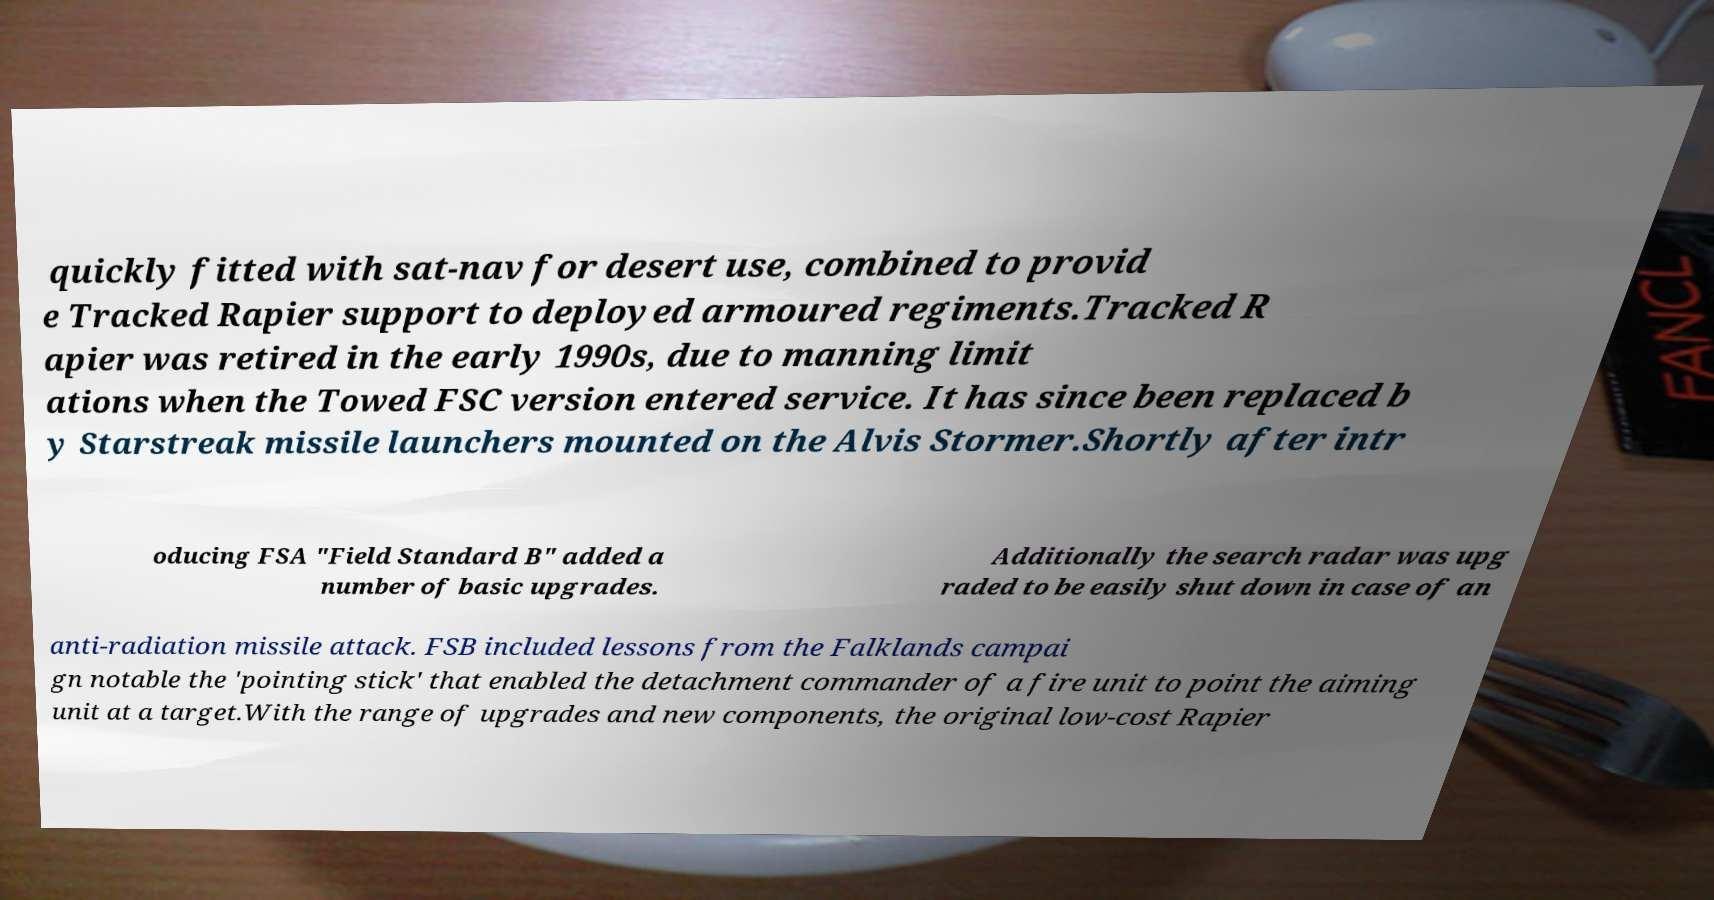I need the written content from this picture converted into text. Can you do that? quickly fitted with sat-nav for desert use, combined to provid e Tracked Rapier support to deployed armoured regiments.Tracked R apier was retired in the early 1990s, due to manning limit ations when the Towed FSC version entered service. It has since been replaced b y Starstreak missile launchers mounted on the Alvis Stormer.Shortly after intr oducing FSA "Field Standard B" added a number of basic upgrades. Additionally the search radar was upg raded to be easily shut down in case of an anti-radiation missile attack. FSB included lessons from the Falklands campai gn notable the 'pointing stick' that enabled the detachment commander of a fire unit to point the aiming unit at a target.With the range of upgrades and new components, the original low-cost Rapier 